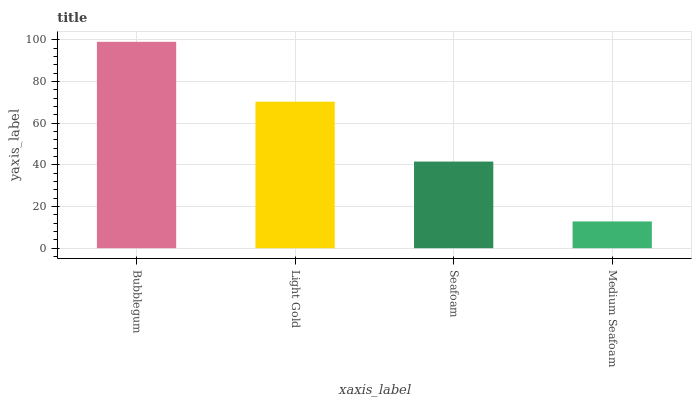Is Medium Seafoam the minimum?
Answer yes or no. Yes. Is Bubblegum the maximum?
Answer yes or no. Yes. Is Light Gold the minimum?
Answer yes or no. No. Is Light Gold the maximum?
Answer yes or no. No. Is Bubblegum greater than Light Gold?
Answer yes or no. Yes. Is Light Gold less than Bubblegum?
Answer yes or no. Yes. Is Light Gold greater than Bubblegum?
Answer yes or no. No. Is Bubblegum less than Light Gold?
Answer yes or no. No. Is Light Gold the high median?
Answer yes or no. Yes. Is Seafoam the low median?
Answer yes or no. Yes. Is Medium Seafoam the high median?
Answer yes or no. No. Is Light Gold the low median?
Answer yes or no. No. 